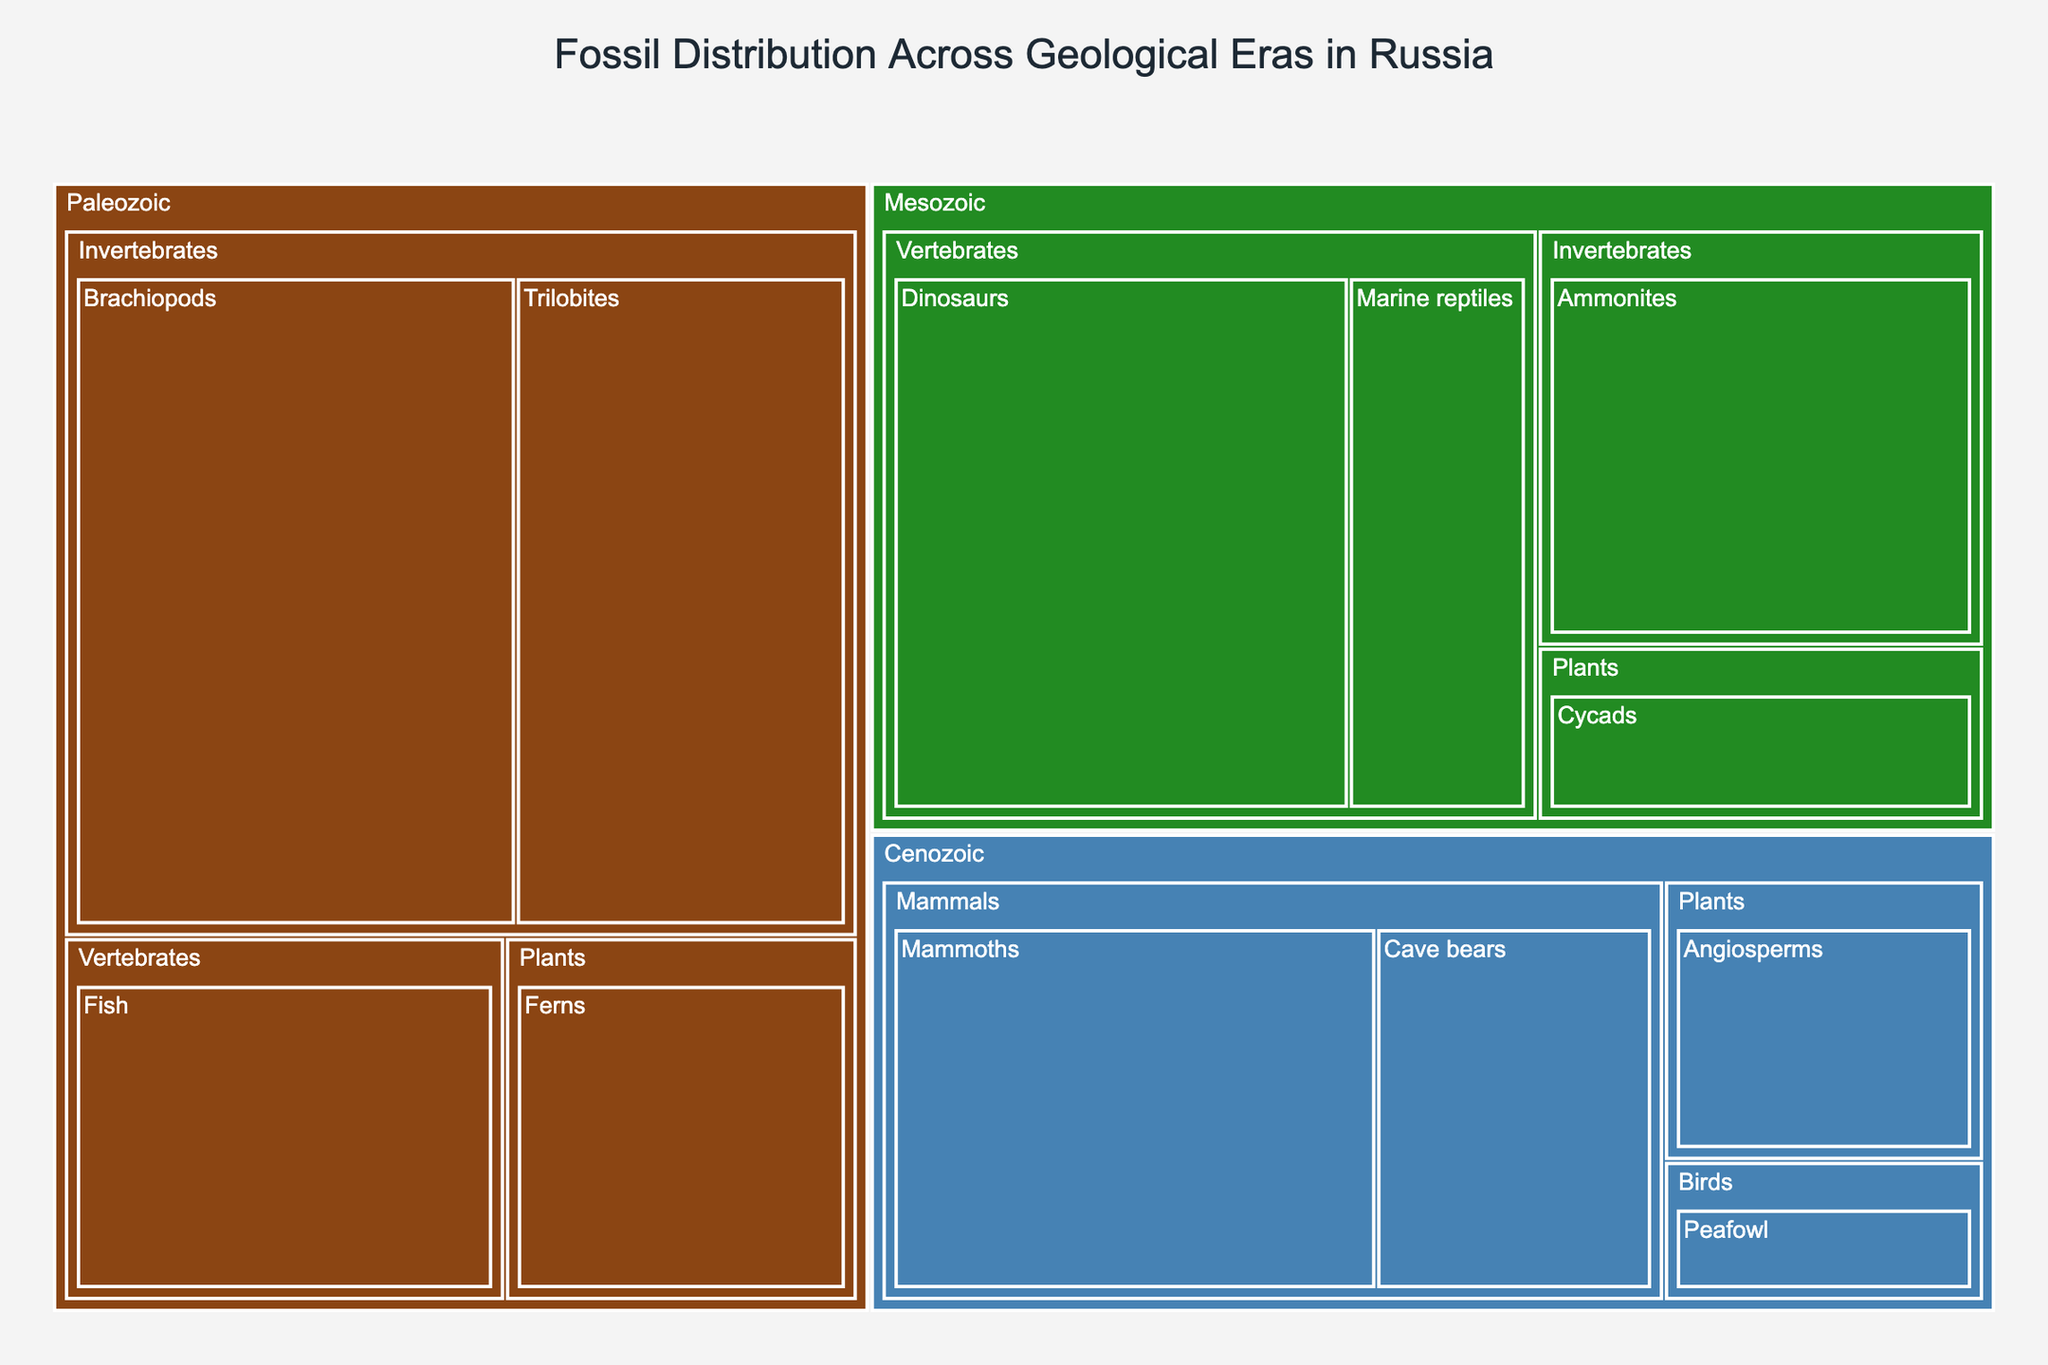What's the title of the figure? The title is usually placed at the top of the figure in a larger and bolder font for emphasis. It summarizes the main point of the visualization.
Answer: Fossil Distribution Across Geological Eras in Russia What color represents the Mesozoic era? The colors in a treemap are used to distinguish between different categories. In this figure, the Mesozoic era is represented by a green color.
Answer: Green How does the percentage of Trilobites compare to the percentage of Dinosaurs? By examining the treemap, we can look at the size and labels of the areas corresponding to Trilobites and Dinosaurs to determine their percentages and compare them. Trilobites have a percentage of 15%, and Dinosaurs have 18%.
Answer: Dinosaurs are 3% more Which subgroup has the smallest representation in the Cenozoic era? Within the Cenozoic division, we look at all the smaller subdivisions (subgroups) and their corresponding percentages to identify the one with the smallest representation.
Answer: Peafowl What is the total percentage of fossils from vertebrates across all eras? We need to sum up all the percentages associated with vertebrates from the three eras. For the Paleozoic: Fish (10%), for the Mesozoic: Dinosaurs (18%) + Marine reptiles (7%), and for the Cenozoic: Mammoths (14%) + Cave bears (8%). Total = 10% + 18% + 7% + 14% + 8% = 57%.
Answer: 57% Which group has a higher percentage in the Paleozoic era, Vertebrates or Invertebrates? In the Paleozoic section, we compare the percentages of vertebrates (Fish, 10%) and invertebrates (Trilobites, 15% + Brachiopods, 20%). For invertebrates, the total is 35%.
Answer: Invertebrates If we combine Cycads and Angiosperms, what percentage of the total do they represent? We need to sum the percentages of Cycads (Mesozoic, 5%) and Angiosperms (Cenozoic, 6%). The combined percentage is 5% + 6% = 11%.
Answer: 11% What is the total percentage of fossils in the Cenozoic era? We sum up all the percentages associated with the Cenozoic era. Cenozoic: Mammoths (14%) + Cave bears (8%) + Peafowl (3%) + Angiosperms (6%). Total = 14% + 8% + 3% + 6% = 31%.
Answer: 31% Which subgroup has the largest percentage in the Mesozoic era? Within the Mesozoic section, we look for the subgroup with the largest number. Ammonites: 12%, Dinosaurs: 18%, Marine reptiles: 7%, Cycads: 5%. Dinosaurs have the highest percentage.
Answer: Dinosaurs What is the difference in percentage between Brachiopods and Angiosperms? By examining Brachiopods (20%) and Angiosperms (6%) on the treemap, we can subtract the smaller value from the larger value to find the difference: 20% - 6% = 14%.
Answer: 14% 